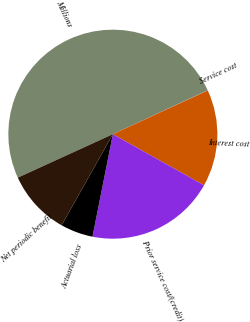<chart> <loc_0><loc_0><loc_500><loc_500><pie_chart><fcel>Millions<fcel>Service cost<fcel>Interest cost<fcel>Prior service cost/(credit)<fcel>Actuarial loss<fcel>Net periodic benefit<nl><fcel>49.9%<fcel>0.05%<fcel>15.0%<fcel>19.99%<fcel>5.03%<fcel>10.02%<nl></chart> 